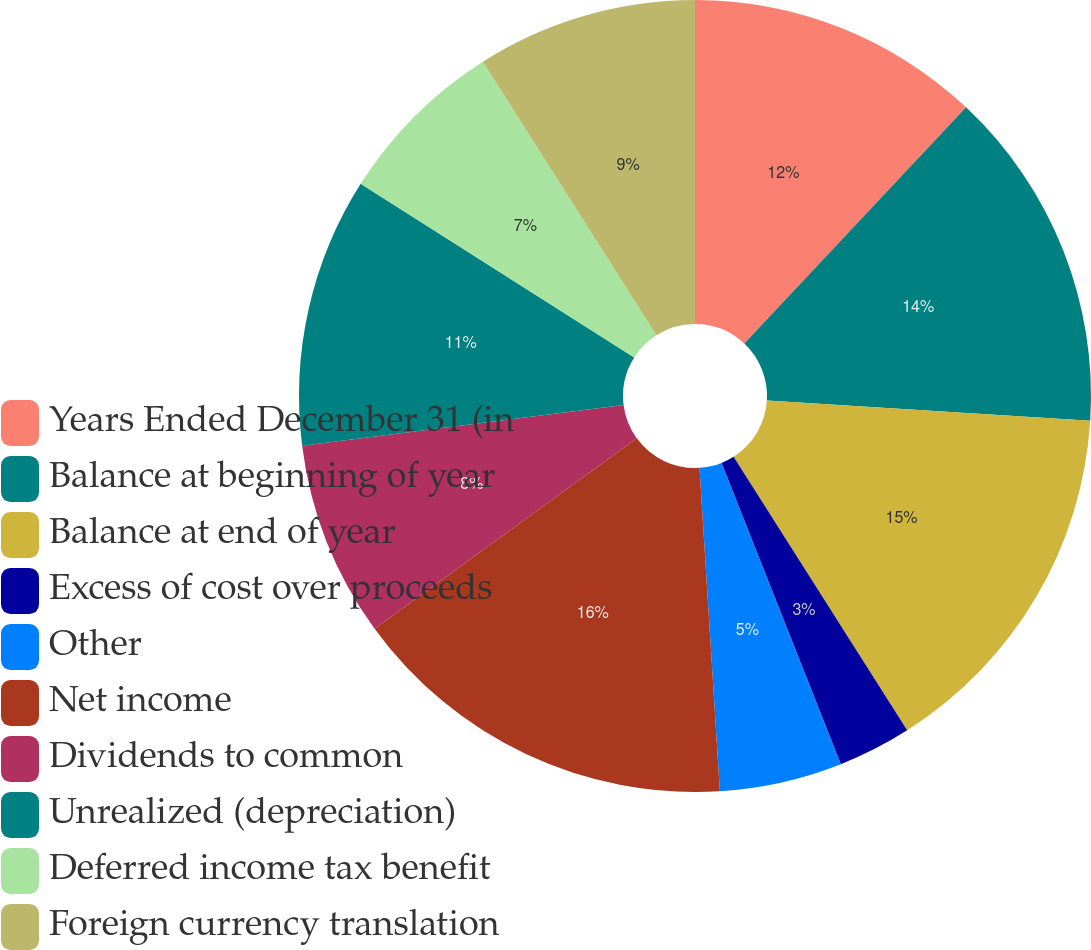Convert chart. <chart><loc_0><loc_0><loc_500><loc_500><pie_chart><fcel>Years Ended December 31 (in<fcel>Balance at beginning of year<fcel>Balance at end of year<fcel>Excess of cost over proceeds<fcel>Other<fcel>Net income<fcel>Dividends to common<fcel>Unrealized (depreciation)<fcel>Deferred income tax benefit<fcel>Foreign currency translation<nl><fcel>12.0%<fcel>14.0%<fcel>15.0%<fcel>3.0%<fcel>5.0%<fcel>16.0%<fcel>8.0%<fcel>11.0%<fcel>7.0%<fcel>9.0%<nl></chart> 